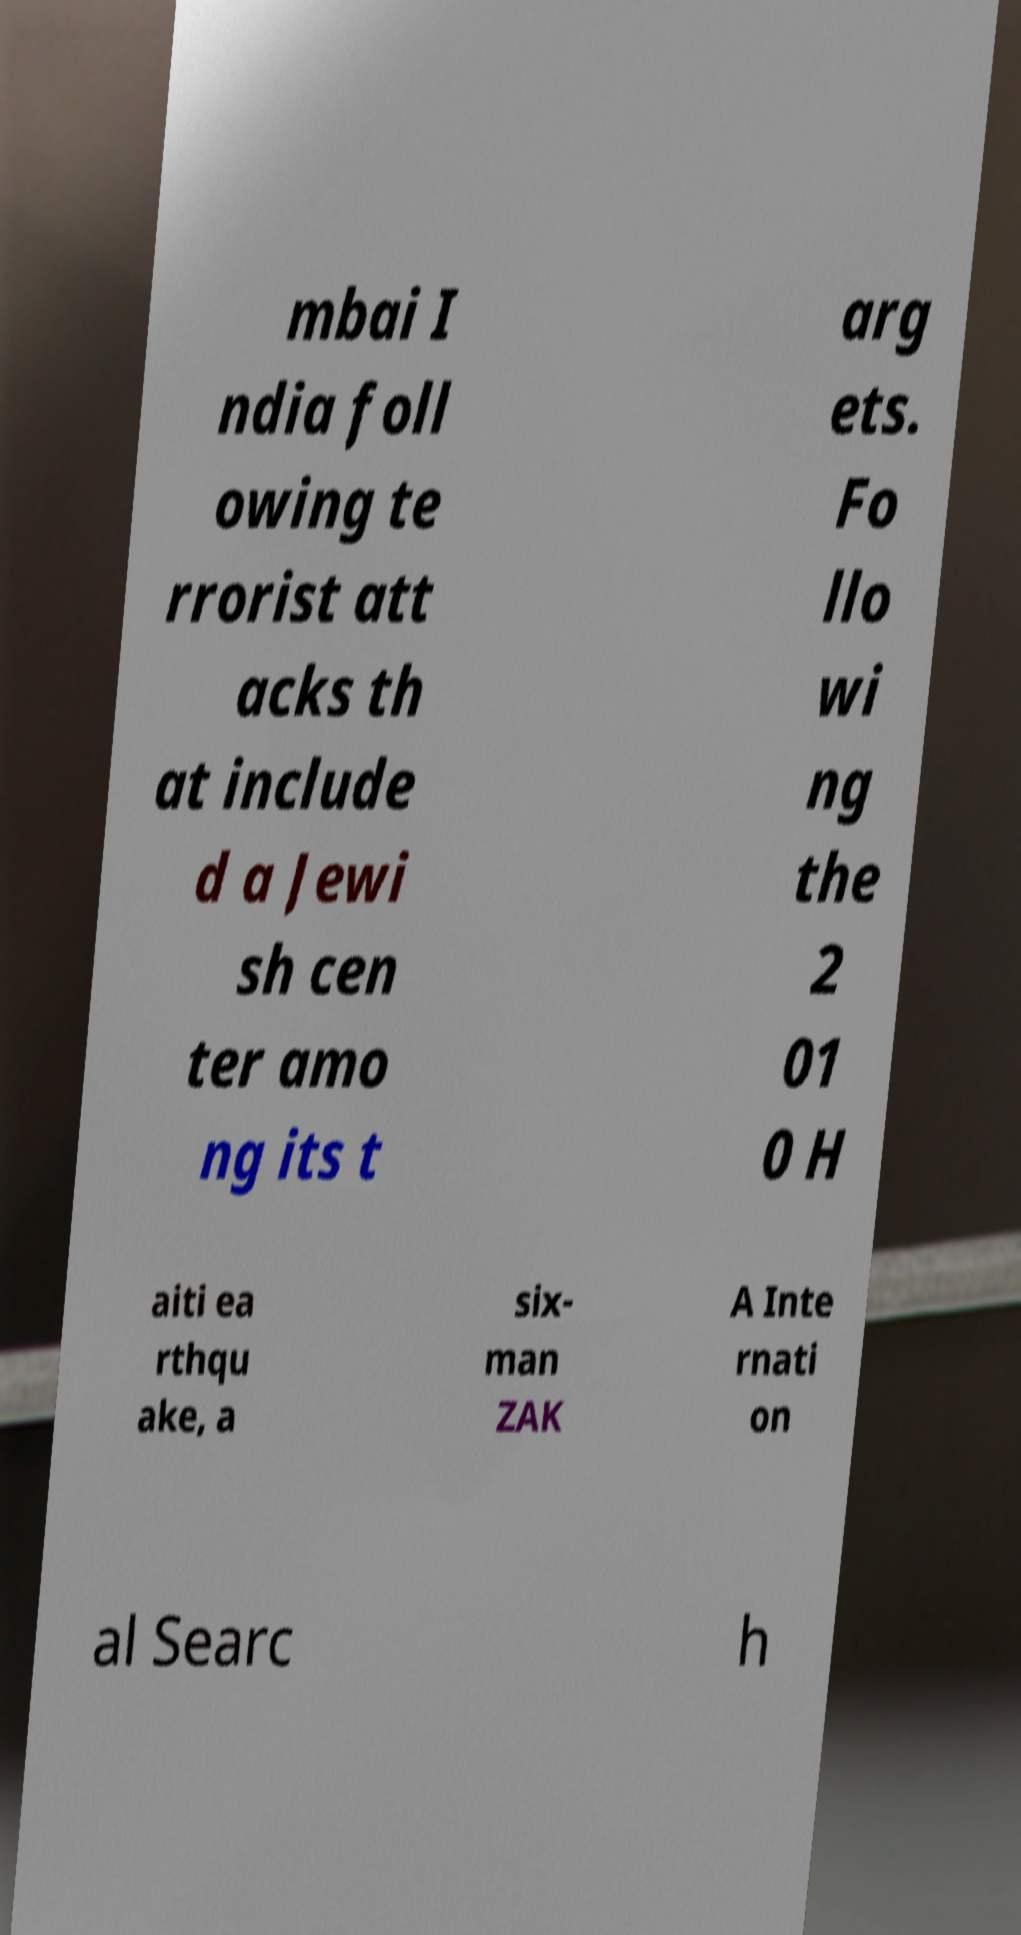Please read and relay the text visible in this image. What does it say? mbai I ndia foll owing te rrorist att acks th at include d a Jewi sh cen ter amo ng its t arg ets. Fo llo wi ng the 2 01 0 H aiti ea rthqu ake, a six- man ZAK A Inte rnati on al Searc h 